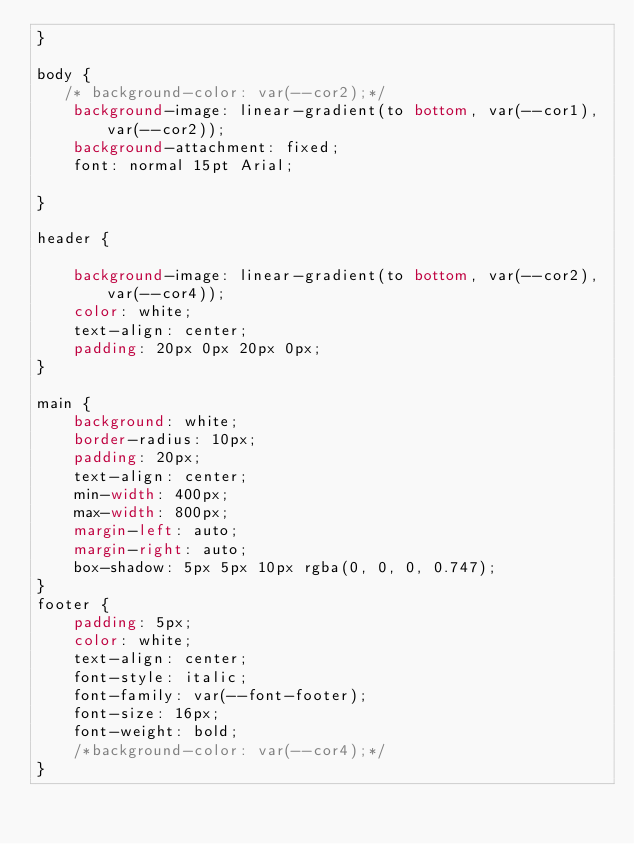<code> <loc_0><loc_0><loc_500><loc_500><_CSS_>}

body {
   /* background-color: var(--cor2);*/
    background-image: linear-gradient(to bottom, var(--cor1), var(--cor2));
    background-attachment: fixed;
    font: normal 15pt Arial;
    
}

header {

    background-image: linear-gradient(to bottom, var(--cor2),var(--cor4));
    color: white;
    text-align: center;
    padding: 20px 0px 20px 0px;
}

main {
    background: white;
    border-radius: 10px;
    padding: 20px;
    text-align: center;
    min-width: 400px;
    max-width: 800px;
    margin-left: auto;
    margin-right: auto;
    box-shadow: 5px 5px 10px rgba(0, 0, 0, 0.747);
}
footer {
    padding: 5px;
    color: white;
    text-align: center;
    font-style: italic;
    font-family: var(--font-footer);
    font-size: 16px;
    font-weight: bold;
    /*background-color: var(--cor4);*/
}</code> 